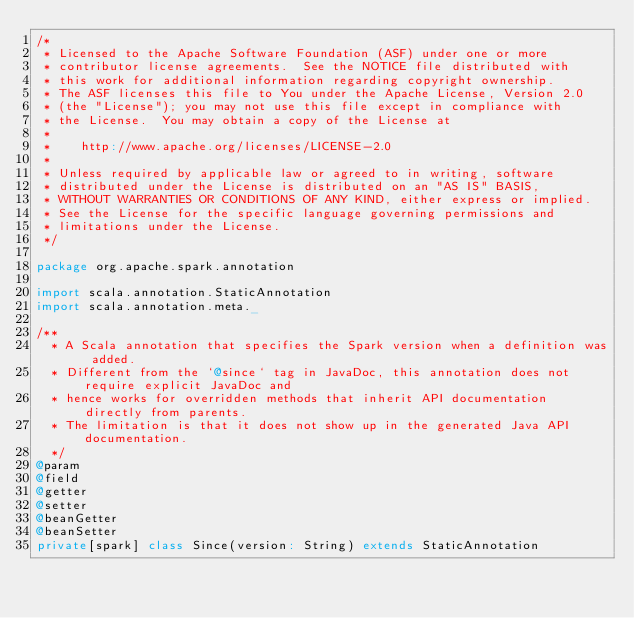Convert code to text. <code><loc_0><loc_0><loc_500><loc_500><_Scala_>/*
 * Licensed to the Apache Software Foundation (ASF) under one or more
 * contributor license agreements.  See the NOTICE file distributed with
 * this work for additional information regarding copyright ownership.
 * The ASF licenses this file to You under the Apache License, Version 2.0
 * (the "License"); you may not use this file except in compliance with
 * the License.  You may obtain a copy of the License at
 *
 *    http://www.apache.org/licenses/LICENSE-2.0
 *
 * Unless required by applicable law or agreed to in writing, software
 * distributed under the License is distributed on an "AS IS" BASIS,
 * WITHOUT WARRANTIES OR CONDITIONS OF ANY KIND, either express or implied.
 * See the License for the specific language governing permissions and
 * limitations under the License.
 */

package org.apache.spark.annotation

import scala.annotation.StaticAnnotation
import scala.annotation.meta._

/**
  * A Scala annotation that specifies the Spark version when a definition was added.
  * Different from the `@since` tag in JavaDoc, this annotation does not require explicit JavaDoc and
  * hence works for overridden methods that inherit API documentation directly from parents.
  * The limitation is that it does not show up in the generated Java API documentation.
  */
@param
@field
@getter
@setter
@beanGetter
@beanSetter
private[spark] class Since(version: String) extends StaticAnnotation
</code> 